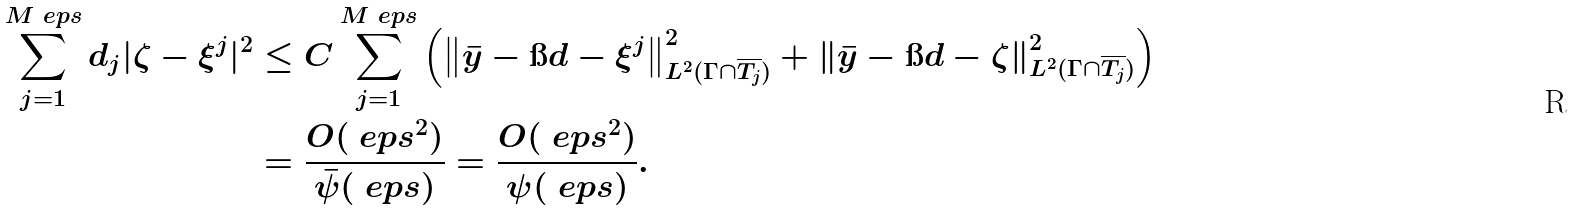Convert formula to latex. <formula><loc_0><loc_0><loc_500><loc_500>\sum ^ { M _ { \ } e p s } _ { j = 1 } d _ { j } | \zeta - \xi ^ { j } | ^ { 2 } & \leq C \sum ^ { M _ { \ } e p s } _ { j = 1 } \left ( \left \| \bar { y } - \i d - \xi ^ { j } \right \| ^ { 2 } _ { L ^ { 2 } ( \Gamma \cap \overline { T _ { j } } ) } + \left \| \bar { y } - \i d - \zeta \right \| ^ { 2 } _ { L ^ { 2 } ( \Gamma \cap \overline { T _ { j } } ) } \right ) \\ & = \frac { O ( \ e p s ^ { 2 } ) } { \bar { \psi } ( \ e p s ) } = \frac { O ( \ e p s ^ { 2 } ) } { \psi ( \ e p s ) } .</formula> 